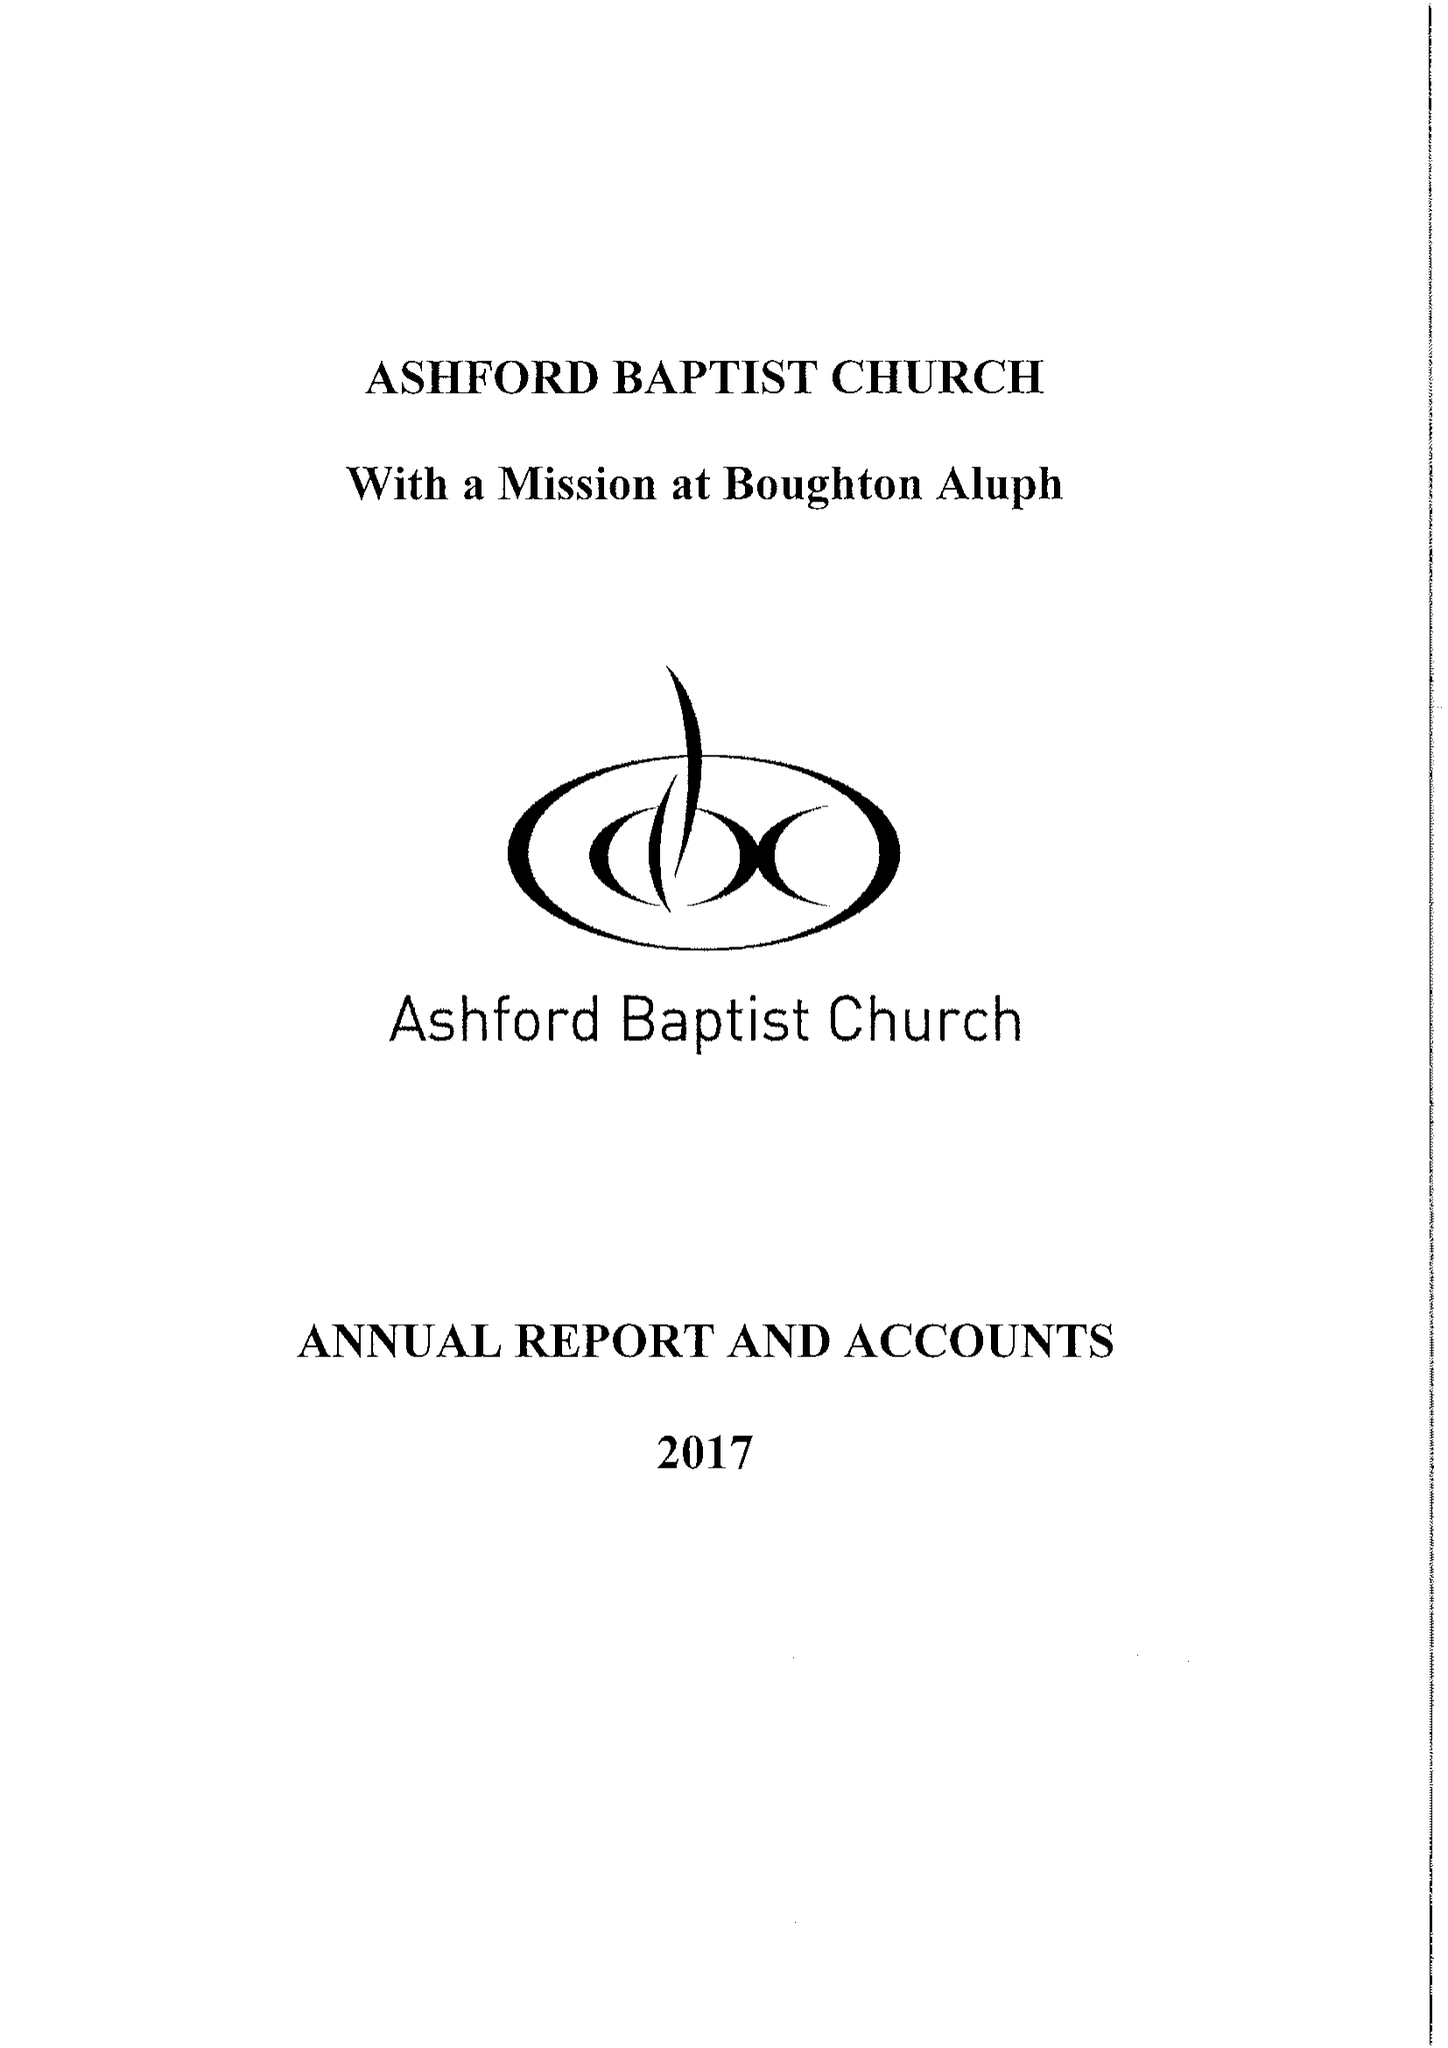What is the value for the address__post_town?
Answer the question using a single word or phrase. ASHFORD 